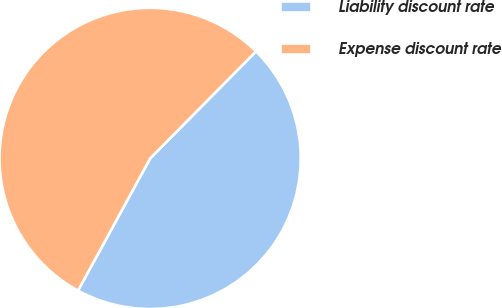Convert chart to OTSL. <chart><loc_0><loc_0><loc_500><loc_500><pie_chart><fcel>Liability discount rate<fcel>Expense discount rate<nl><fcel>45.54%<fcel>54.46%<nl></chart> 